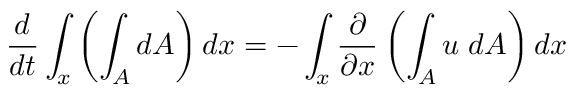Convert formula to latex. <formula><loc_0><loc_0><loc_500><loc_500>{ \frac { d } { d t } } \int _ { x } \left ( \int _ { A } d A \right ) d x = - \int _ { x } { \frac { \partial } { \partial x } } \left ( \int _ { A } u \, d A \right ) d x</formula> 